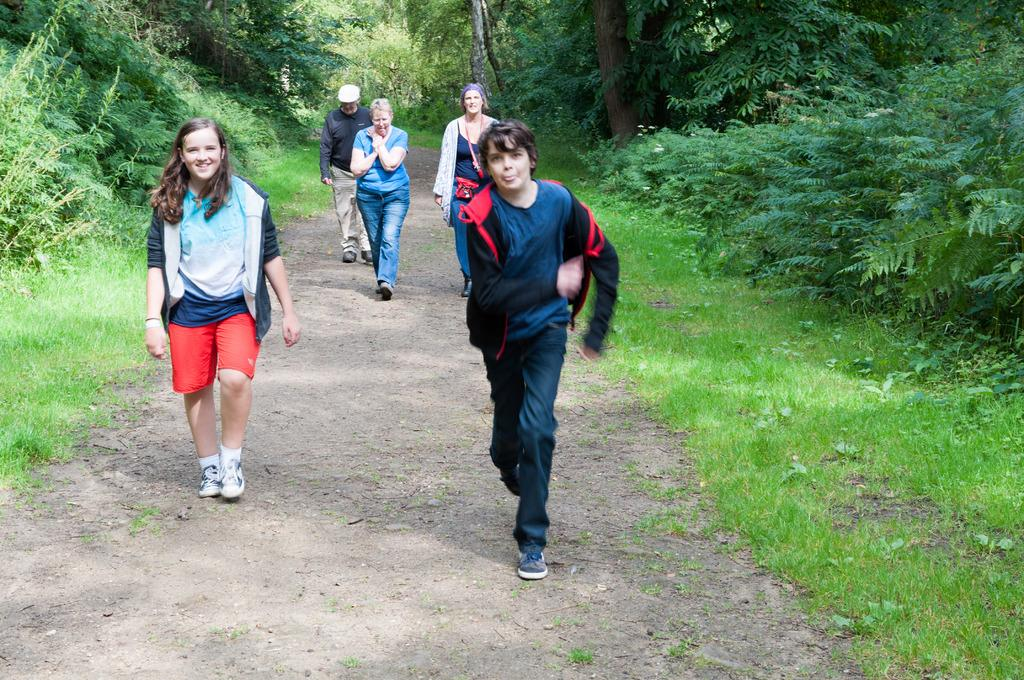What is the main subject in the foreground of the image? There is a boy running in the foreground of the image. Where is the boy running? The boy is on a path. How many people are walking on the path? There are four people walking on the path. What can be seen on either side of the path? There is grass and trees on either side of the path. What type of trousers is the weather wearing in the image? There is no weather depicted in the image, and therefore no trousers can be attributed to it. What is the current state of the grass on either side of the path? The provided facts do not mention the current state of the grass, so it cannot be determined from the image. 